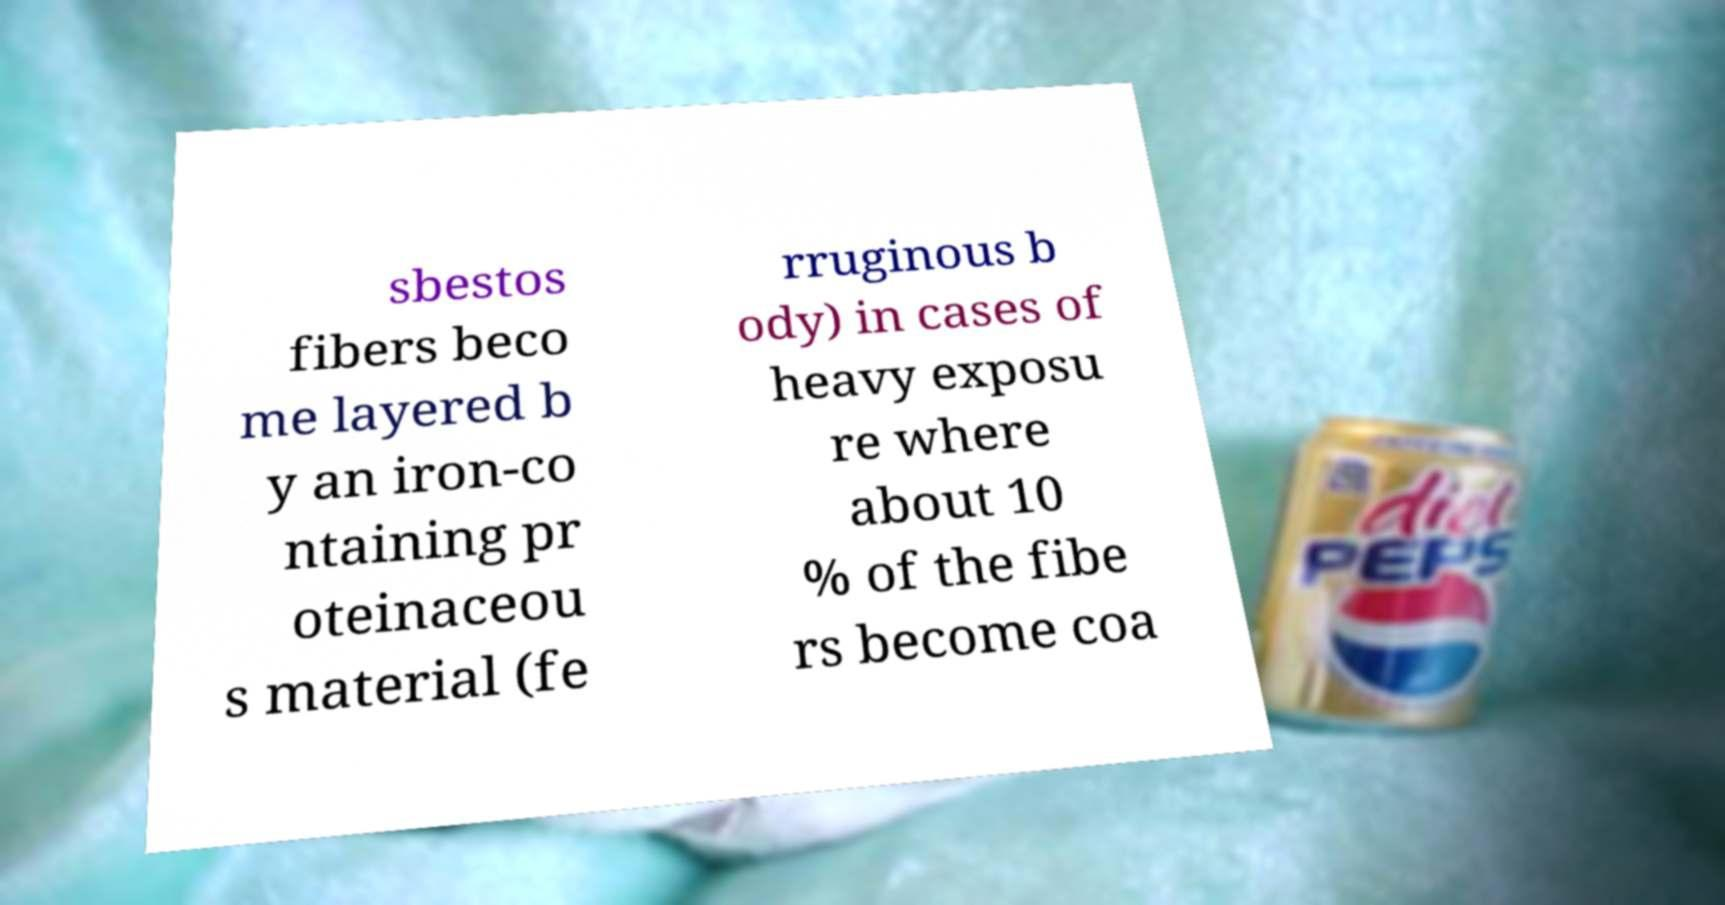Could you extract and type out the text from this image? sbestos fibers beco me layered b y an iron-co ntaining pr oteinaceou s material (fe rruginous b ody) in cases of heavy exposu re where about 10 % of the fibe rs become coa 